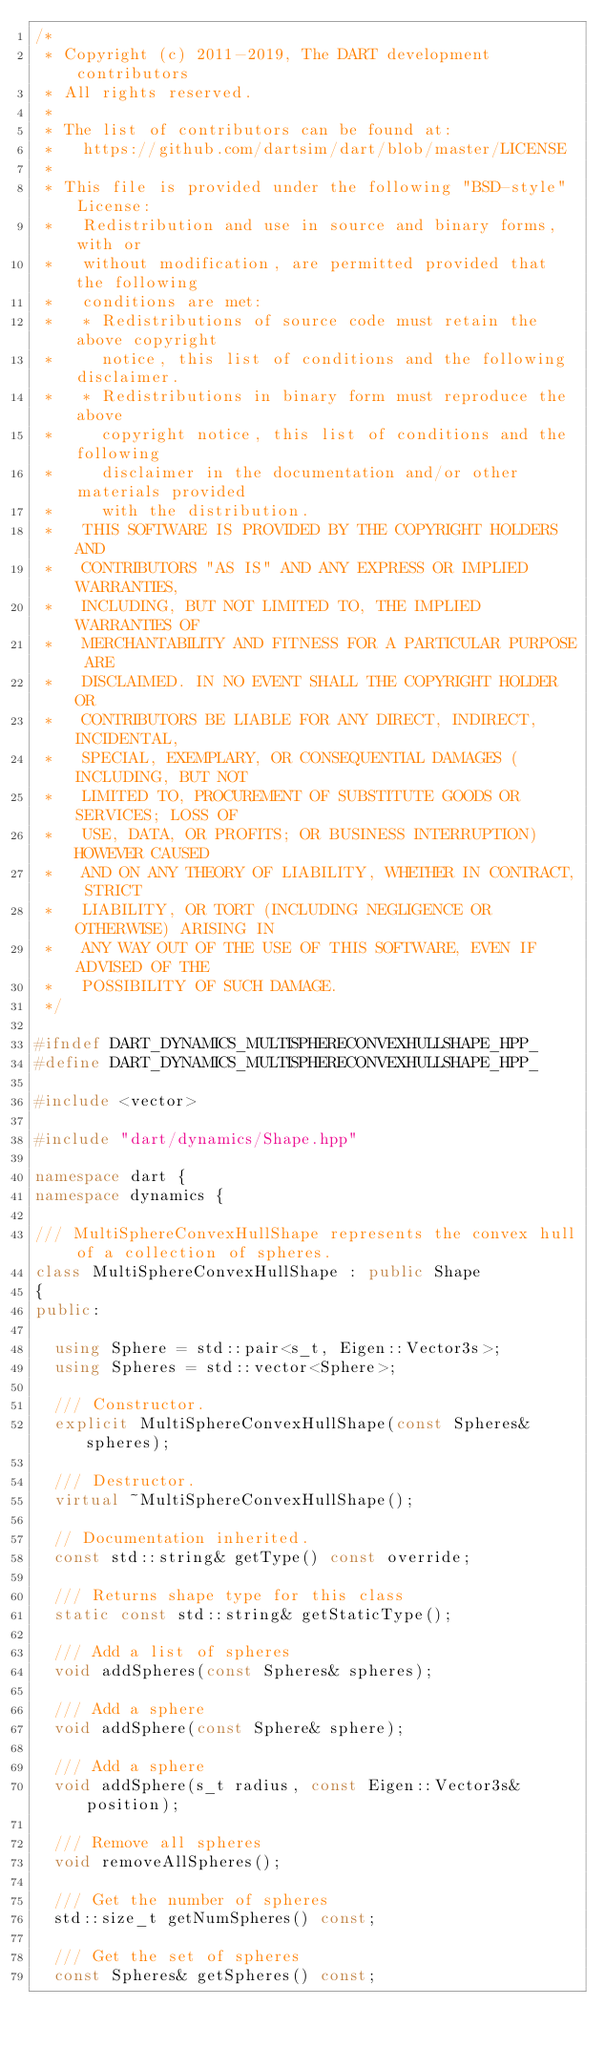<code> <loc_0><loc_0><loc_500><loc_500><_C++_>/*
 * Copyright (c) 2011-2019, The DART development contributors
 * All rights reserved.
 *
 * The list of contributors can be found at:
 *   https://github.com/dartsim/dart/blob/master/LICENSE
 *
 * This file is provided under the following "BSD-style" License:
 *   Redistribution and use in source and binary forms, with or
 *   without modification, are permitted provided that the following
 *   conditions are met:
 *   * Redistributions of source code must retain the above copyright
 *     notice, this list of conditions and the following disclaimer.
 *   * Redistributions in binary form must reproduce the above
 *     copyright notice, this list of conditions and the following
 *     disclaimer in the documentation and/or other materials provided
 *     with the distribution.
 *   THIS SOFTWARE IS PROVIDED BY THE COPYRIGHT HOLDERS AND
 *   CONTRIBUTORS "AS IS" AND ANY EXPRESS OR IMPLIED WARRANTIES,
 *   INCLUDING, BUT NOT LIMITED TO, THE IMPLIED WARRANTIES OF
 *   MERCHANTABILITY AND FITNESS FOR A PARTICULAR PURPOSE ARE
 *   DISCLAIMED. IN NO EVENT SHALL THE COPYRIGHT HOLDER OR
 *   CONTRIBUTORS BE LIABLE FOR ANY DIRECT, INDIRECT, INCIDENTAL,
 *   SPECIAL, EXEMPLARY, OR CONSEQUENTIAL DAMAGES (INCLUDING, BUT NOT
 *   LIMITED TO, PROCUREMENT OF SUBSTITUTE GOODS OR SERVICES; LOSS OF
 *   USE, DATA, OR PROFITS; OR BUSINESS INTERRUPTION) HOWEVER CAUSED
 *   AND ON ANY THEORY OF LIABILITY, WHETHER IN CONTRACT, STRICT
 *   LIABILITY, OR TORT (INCLUDING NEGLIGENCE OR OTHERWISE) ARISING IN
 *   ANY WAY OUT OF THE USE OF THIS SOFTWARE, EVEN IF ADVISED OF THE
 *   POSSIBILITY OF SUCH DAMAGE.
 */

#ifndef DART_DYNAMICS_MULTISPHERECONVEXHULLSHAPE_HPP_
#define DART_DYNAMICS_MULTISPHERECONVEXHULLSHAPE_HPP_

#include <vector>

#include "dart/dynamics/Shape.hpp"

namespace dart {
namespace dynamics {

/// MultiSphereConvexHullShape represents the convex hull of a collection of spheres.
class MultiSphereConvexHullShape : public Shape
{
public:

  using Sphere = std::pair<s_t, Eigen::Vector3s>;
  using Spheres = std::vector<Sphere>;

  /// Constructor.
  explicit MultiSphereConvexHullShape(const Spheres& spheres);

  /// Destructor.
  virtual ~MultiSphereConvexHullShape();

  // Documentation inherited.
  const std::string& getType() const override;

  /// Returns shape type for this class
  static const std::string& getStaticType();

  /// Add a list of spheres
  void addSpheres(const Spheres& spheres);

  /// Add a sphere
  void addSphere(const Sphere& sphere);

  /// Add a sphere
  void addSphere(s_t radius, const Eigen::Vector3s& position);

  /// Remove all spheres
  void removeAllSpheres();

  /// Get the number of spheres
  std::size_t getNumSpheres() const;

  /// Get the set of spheres
  const Spheres& getSpheres() const;
</code> 